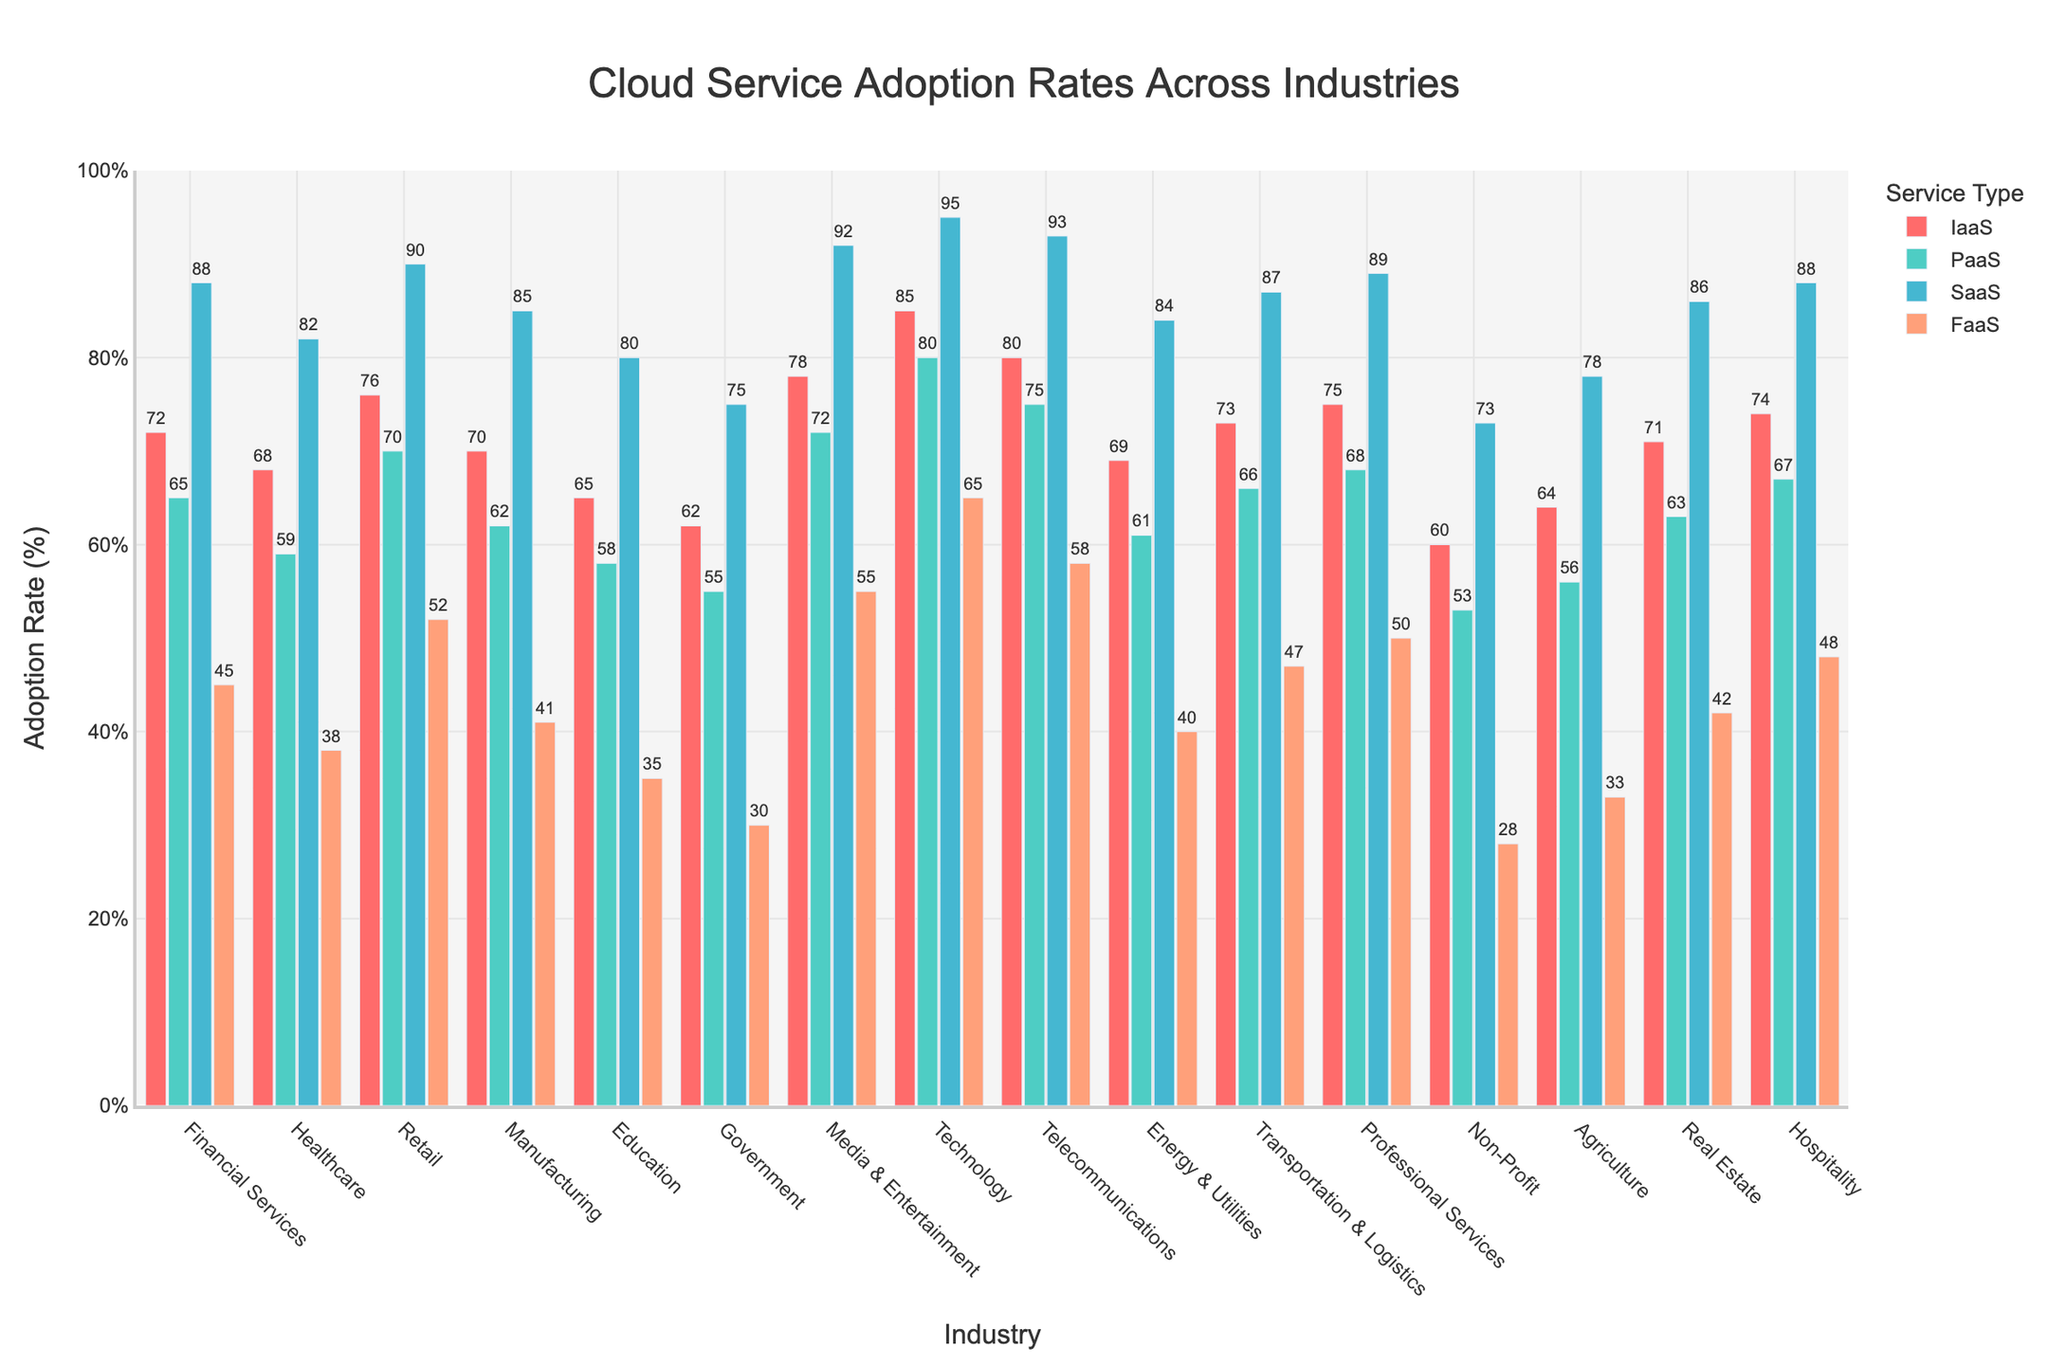What's the industry with the highest adoption rate for SaaS? To find the industry with the highest SaaS adoption rate, we need to identify the tallest bar for SaaS, which is represented in blue. Upon inspection, the tallest blue bar is for the Technology industry.
Answer: Technology Which industry has the lowest adoption rate for FaaS? The lowest adoption rate for FaaS (orange bars) is seen by identifying the shortest orange bar. The shortest bar is for the Non-Profit industry, indicating the lowest FaaS adoption rate.
Answer: Non-Profit Compare the PaaS adoption rates between the Financial Services and Government industries. Which one is higher and by how much? Look at the PaaS (green bars) for both Financial Services and Government. Financial Services has 65% and Government has 55%. Subtract Government's rate from Financial Services' rate: 65% - 55% = 10%.
Answer: Financial Services by 10% What is the average adoption rate of IaaS across all industries? Sum the IaaS adoption rates of each industry and then divide by the number of industries. The total is (72 + 68 + 76 + 70 + 65 + 62 + 78 + 85 + 80 + 69 + 73 + 75 + 60 + 64 + 71 + 74) = 1122. There are 16 industries. Average is 1122/16 = 70.125%.
Answer: 70.125% Determine the difference in adoption rates for SaaS between Retail and Agriculture. Look at the SaaS adoption rates for Retail and Agriculture. Retail has 90% and Agriculture has 78%. Subtract Agriculture's rate from Retail's rate: 90% - 78% = 12%.
Answer: 12% Which industry shows the most balanced adoption rates across all four services and which one shows the most disparity? A balanced adoption rate would have bars of nearly equal height across all four services; disparity would have notably unequal heights. The Technology industry is quite balanced with adoption rates of 85%, 80%, 95%, and 65%. The Government industry shows disparity with rates of 62%, 55%, 75%, and 30%.
Answer: Most balanced: Technology, Most disparity: Government What's the difference between the highest and lowest adoption rates for PaaS? Identify the maximum and minimum PaaS adoption rates. Maximum is Technology at 80%, and minimum is Non-Profit at 53%. Difference: 80% - 53% = 27%.
Answer: 27% Do Financial Services or Media & Entertainment industries have higher FaaS adoption rates? By how much? Compare the FaaS adoption rates (orange bars) for Financial Services and Media & Entertainment. Financial Services has 45% and Media & Entertainment has 55%. Subtract Financial Services' rate from Media & Entertainment's rate: 55% - 45% = 10%.
Answer: Media & Entertainment by 10% Which three industries have the highest IaaS adoption rates? Identify the three tallest red bars, which represent IaaS adoption rates. The tallest bars are for Technology (85%), Telecommunications (80%), and Retail (76%).
Answer: Technology, Telecommunications, Retail 